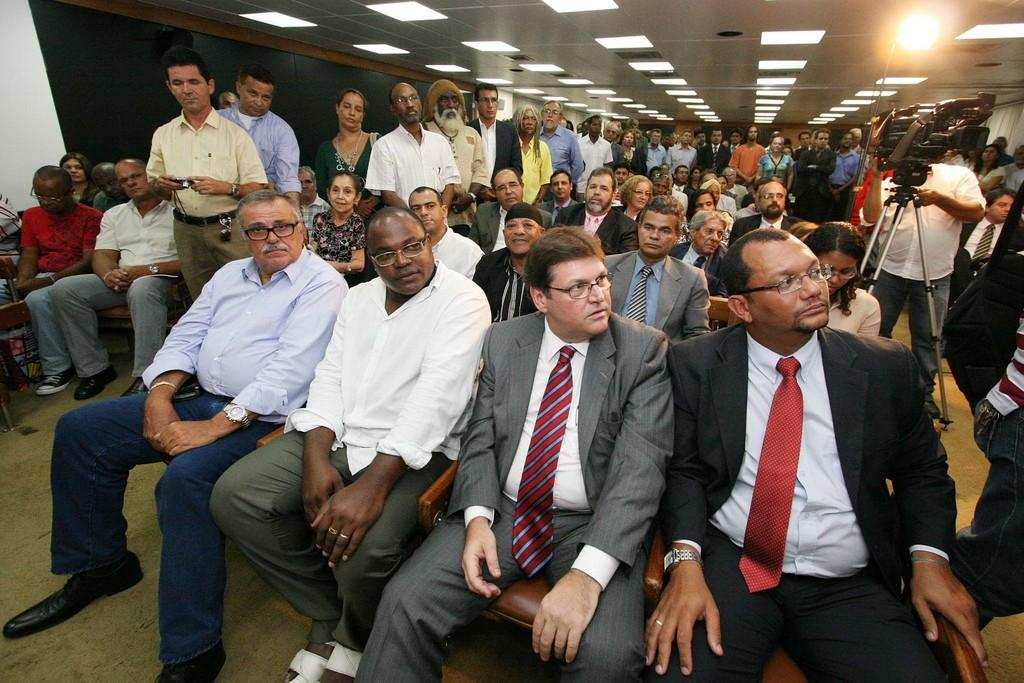How many people are present in the image? There are many people in the image. What are the people doing in the image? The people are sitting and standing inside a meeting hall. Can you describe the person with a camera in the image? There is a person with a camera on the right side of the image. What is the lighting situation in the meeting hall? There are lights over the ceiling in the image. What color is the cat sitting next to the person with a camera in the image? There is no cat present in the image. How does the sister of the person with a camera feel about the meeting in the image? There is no mention of a sister in the image or the provided facts. 